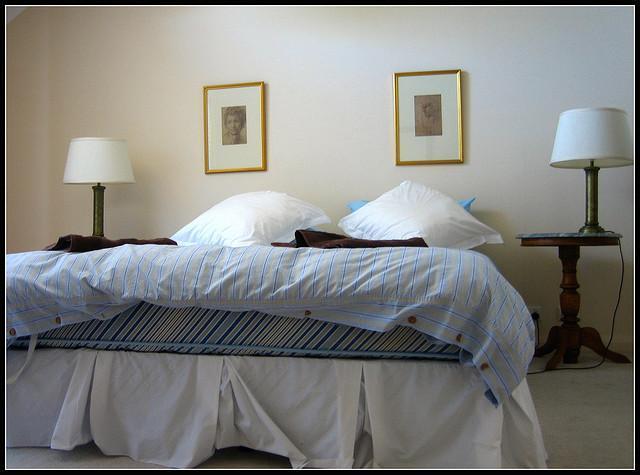How many table lamps do you see?
Give a very brief answer. 2. How many pillows are on the bed?
Give a very brief answer. 3. How many benches are there?
Give a very brief answer. 0. 